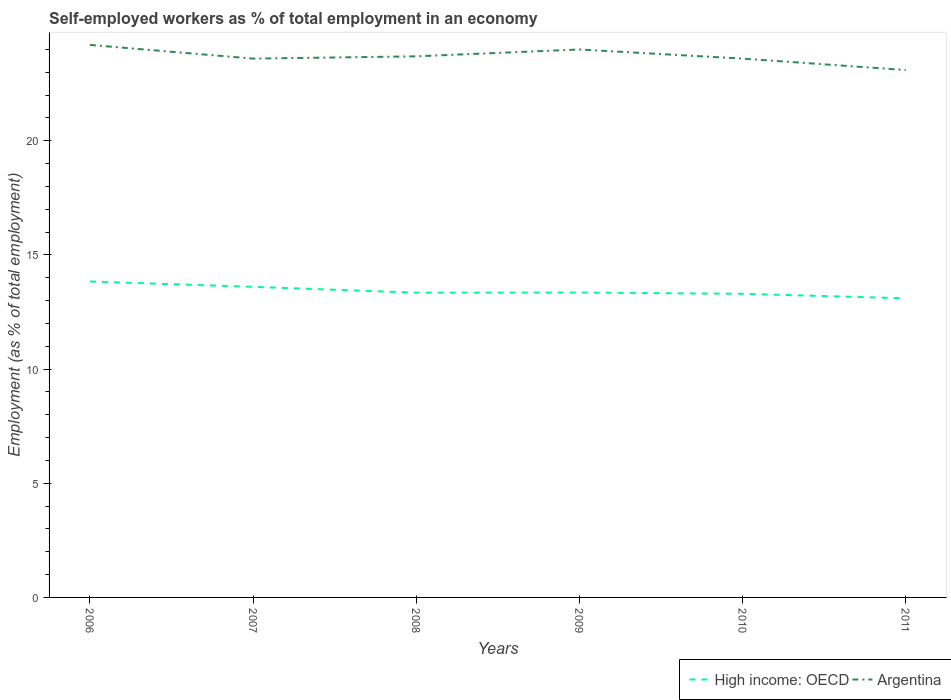Is the number of lines equal to the number of legend labels?
Offer a very short reply. Yes. Across all years, what is the maximum percentage of self-employed workers in Argentina?
Offer a very short reply. 23.1. In which year was the percentage of self-employed workers in High income: OECD maximum?
Ensure brevity in your answer.  2011. What is the total percentage of self-employed workers in High income: OECD in the graph?
Your response must be concise. 0.26. What is the difference between the highest and the second highest percentage of self-employed workers in High income: OECD?
Your answer should be compact. 0.74. How many years are there in the graph?
Offer a very short reply. 6. What is the difference between two consecutive major ticks on the Y-axis?
Your answer should be very brief. 5. Does the graph contain any zero values?
Offer a terse response. No. Does the graph contain grids?
Your answer should be very brief. No. How many legend labels are there?
Your answer should be compact. 2. How are the legend labels stacked?
Your answer should be very brief. Horizontal. What is the title of the graph?
Keep it short and to the point. Self-employed workers as % of total employment in an economy. What is the label or title of the X-axis?
Your answer should be very brief. Years. What is the label or title of the Y-axis?
Give a very brief answer. Employment (as % of total employment). What is the Employment (as % of total employment) in High income: OECD in 2006?
Offer a very short reply. 13.84. What is the Employment (as % of total employment) in Argentina in 2006?
Keep it short and to the point. 24.2. What is the Employment (as % of total employment) of High income: OECD in 2007?
Give a very brief answer. 13.6. What is the Employment (as % of total employment) of Argentina in 2007?
Your answer should be compact. 23.6. What is the Employment (as % of total employment) of High income: OECD in 2008?
Your answer should be compact. 13.35. What is the Employment (as % of total employment) of Argentina in 2008?
Give a very brief answer. 23.7. What is the Employment (as % of total employment) of High income: OECD in 2009?
Offer a very short reply. 13.35. What is the Employment (as % of total employment) in Argentina in 2009?
Offer a very short reply. 24. What is the Employment (as % of total employment) of High income: OECD in 2010?
Ensure brevity in your answer.  13.3. What is the Employment (as % of total employment) in Argentina in 2010?
Ensure brevity in your answer.  23.6. What is the Employment (as % of total employment) in High income: OECD in 2011?
Provide a succinct answer. 13.1. What is the Employment (as % of total employment) of Argentina in 2011?
Your response must be concise. 23.1. Across all years, what is the maximum Employment (as % of total employment) of High income: OECD?
Ensure brevity in your answer.  13.84. Across all years, what is the maximum Employment (as % of total employment) of Argentina?
Offer a terse response. 24.2. Across all years, what is the minimum Employment (as % of total employment) in High income: OECD?
Provide a short and direct response. 13.1. Across all years, what is the minimum Employment (as % of total employment) in Argentina?
Offer a terse response. 23.1. What is the total Employment (as % of total employment) of High income: OECD in the graph?
Your response must be concise. 80.55. What is the total Employment (as % of total employment) in Argentina in the graph?
Your response must be concise. 142.2. What is the difference between the Employment (as % of total employment) in High income: OECD in 2006 and that in 2007?
Ensure brevity in your answer.  0.23. What is the difference between the Employment (as % of total employment) in Argentina in 2006 and that in 2007?
Your answer should be very brief. 0.6. What is the difference between the Employment (as % of total employment) in High income: OECD in 2006 and that in 2008?
Provide a succinct answer. 0.49. What is the difference between the Employment (as % of total employment) in High income: OECD in 2006 and that in 2009?
Keep it short and to the point. 0.48. What is the difference between the Employment (as % of total employment) of High income: OECD in 2006 and that in 2010?
Keep it short and to the point. 0.54. What is the difference between the Employment (as % of total employment) in Argentina in 2006 and that in 2010?
Offer a terse response. 0.6. What is the difference between the Employment (as % of total employment) of High income: OECD in 2006 and that in 2011?
Your answer should be compact. 0.74. What is the difference between the Employment (as % of total employment) of Argentina in 2006 and that in 2011?
Provide a succinct answer. 1.1. What is the difference between the Employment (as % of total employment) of High income: OECD in 2007 and that in 2008?
Keep it short and to the point. 0.26. What is the difference between the Employment (as % of total employment) in Argentina in 2007 and that in 2008?
Provide a short and direct response. -0.1. What is the difference between the Employment (as % of total employment) in High income: OECD in 2007 and that in 2009?
Your answer should be very brief. 0.25. What is the difference between the Employment (as % of total employment) of Argentina in 2007 and that in 2009?
Your response must be concise. -0.4. What is the difference between the Employment (as % of total employment) in High income: OECD in 2007 and that in 2010?
Offer a very short reply. 0.31. What is the difference between the Employment (as % of total employment) of Argentina in 2007 and that in 2010?
Your answer should be compact. 0. What is the difference between the Employment (as % of total employment) of High income: OECD in 2007 and that in 2011?
Your answer should be compact. 0.5. What is the difference between the Employment (as % of total employment) of High income: OECD in 2008 and that in 2009?
Ensure brevity in your answer.  -0.01. What is the difference between the Employment (as % of total employment) of High income: OECD in 2008 and that in 2010?
Offer a very short reply. 0.05. What is the difference between the Employment (as % of total employment) in High income: OECD in 2008 and that in 2011?
Give a very brief answer. 0.25. What is the difference between the Employment (as % of total employment) of Argentina in 2008 and that in 2011?
Offer a terse response. 0.6. What is the difference between the Employment (as % of total employment) in High income: OECD in 2009 and that in 2010?
Offer a terse response. 0.06. What is the difference between the Employment (as % of total employment) in High income: OECD in 2009 and that in 2011?
Make the answer very short. 0.25. What is the difference between the Employment (as % of total employment) in Argentina in 2009 and that in 2011?
Ensure brevity in your answer.  0.9. What is the difference between the Employment (as % of total employment) of High income: OECD in 2010 and that in 2011?
Your response must be concise. 0.2. What is the difference between the Employment (as % of total employment) in Argentina in 2010 and that in 2011?
Offer a very short reply. 0.5. What is the difference between the Employment (as % of total employment) of High income: OECD in 2006 and the Employment (as % of total employment) of Argentina in 2007?
Provide a short and direct response. -9.76. What is the difference between the Employment (as % of total employment) of High income: OECD in 2006 and the Employment (as % of total employment) of Argentina in 2008?
Your answer should be very brief. -9.86. What is the difference between the Employment (as % of total employment) in High income: OECD in 2006 and the Employment (as % of total employment) in Argentina in 2009?
Your answer should be compact. -10.16. What is the difference between the Employment (as % of total employment) of High income: OECD in 2006 and the Employment (as % of total employment) of Argentina in 2010?
Provide a succinct answer. -9.76. What is the difference between the Employment (as % of total employment) of High income: OECD in 2006 and the Employment (as % of total employment) of Argentina in 2011?
Provide a short and direct response. -9.26. What is the difference between the Employment (as % of total employment) of High income: OECD in 2007 and the Employment (as % of total employment) of Argentina in 2008?
Keep it short and to the point. -10.1. What is the difference between the Employment (as % of total employment) of High income: OECD in 2007 and the Employment (as % of total employment) of Argentina in 2009?
Provide a short and direct response. -10.4. What is the difference between the Employment (as % of total employment) in High income: OECD in 2007 and the Employment (as % of total employment) in Argentina in 2010?
Offer a terse response. -10. What is the difference between the Employment (as % of total employment) in High income: OECD in 2007 and the Employment (as % of total employment) in Argentina in 2011?
Your answer should be compact. -9.5. What is the difference between the Employment (as % of total employment) of High income: OECD in 2008 and the Employment (as % of total employment) of Argentina in 2009?
Make the answer very short. -10.65. What is the difference between the Employment (as % of total employment) in High income: OECD in 2008 and the Employment (as % of total employment) in Argentina in 2010?
Ensure brevity in your answer.  -10.25. What is the difference between the Employment (as % of total employment) in High income: OECD in 2008 and the Employment (as % of total employment) in Argentina in 2011?
Ensure brevity in your answer.  -9.75. What is the difference between the Employment (as % of total employment) in High income: OECD in 2009 and the Employment (as % of total employment) in Argentina in 2010?
Your answer should be very brief. -10.25. What is the difference between the Employment (as % of total employment) in High income: OECD in 2009 and the Employment (as % of total employment) in Argentina in 2011?
Ensure brevity in your answer.  -9.75. What is the difference between the Employment (as % of total employment) in High income: OECD in 2010 and the Employment (as % of total employment) in Argentina in 2011?
Your answer should be very brief. -9.8. What is the average Employment (as % of total employment) of High income: OECD per year?
Ensure brevity in your answer.  13.42. What is the average Employment (as % of total employment) of Argentina per year?
Provide a short and direct response. 23.7. In the year 2006, what is the difference between the Employment (as % of total employment) in High income: OECD and Employment (as % of total employment) in Argentina?
Your response must be concise. -10.36. In the year 2007, what is the difference between the Employment (as % of total employment) in High income: OECD and Employment (as % of total employment) in Argentina?
Give a very brief answer. -10. In the year 2008, what is the difference between the Employment (as % of total employment) in High income: OECD and Employment (as % of total employment) in Argentina?
Your answer should be very brief. -10.35. In the year 2009, what is the difference between the Employment (as % of total employment) in High income: OECD and Employment (as % of total employment) in Argentina?
Your answer should be compact. -10.65. In the year 2010, what is the difference between the Employment (as % of total employment) in High income: OECD and Employment (as % of total employment) in Argentina?
Offer a terse response. -10.3. In the year 2011, what is the difference between the Employment (as % of total employment) of High income: OECD and Employment (as % of total employment) of Argentina?
Your answer should be very brief. -10. What is the ratio of the Employment (as % of total employment) of High income: OECD in 2006 to that in 2007?
Offer a very short reply. 1.02. What is the ratio of the Employment (as % of total employment) of Argentina in 2006 to that in 2007?
Your response must be concise. 1.03. What is the ratio of the Employment (as % of total employment) of High income: OECD in 2006 to that in 2008?
Your answer should be very brief. 1.04. What is the ratio of the Employment (as % of total employment) of Argentina in 2006 to that in 2008?
Your response must be concise. 1.02. What is the ratio of the Employment (as % of total employment) in High income: OECD in 2006 to that in 2009?
Your response must be concise. 1.04. What is the ratio of the Employment (as % of total employment) of Argentina in 2006 to that in 2009?
Make the answer very short. 1.01. What is the ratio of the Employment (as % of total employment) of High income: OECD in 2006 to that in 2010?
Give a very brief answer. 1.04. What is the ratio of the Employment (as % of total employment) in Argentina in 2006 to that in 2010?
Give a very brief answer. 1.03. What is the ratio of the Employment (as % of total employment) of High income: OECD in 2006 to that in 2011?
Your response must be concise. 1.06. What is the ratio of the Employment (as % of total employment) in Argentina in 2006 to that in 2011?
Provide a short and direct response. 1.05. What is the ratio of the Employment (as % of total employment) of High income: OECD in 2007 to that in 2008?
Give a very brief answer. 1.02. What is the ratio of the Employment (as % of total employment) in Argentina in 2007 to that in 2008?
Provide a short and direct response. 1. What is the ratio of the Employment (as % of total employment) of High income: OECD in 2007 to that in 2009?
Your response must be concise. 1.02. What is the ratio of the Employment (as % of total employment) in Argentina in 2007 to that in 2009?
Give a very brief answer. 0.98. What is the ratio of the Employment (as % of total employment) in High income: OECD in 2007 to that in 2011?
Offer a terse response. 1.04. What is the ratio of the Employment (as % of total employment) of Argentina in 2007 to that in 2011?
Ensure brevity in your answer.  1.02. What is the ratio of the Employment (as % of total employment) in Argentina in 2008 to that in 2009?
Keep it short and to the point. 0.99. What is the ratio of the Employment (as % of total employment) of High income: OECD in 2008 to that in 2010?
Your answer should be compact. 1. What is the ratio of the Employment (as % of total employment) of High income: OECD in 2008 to that in 2011?
Your answer should be very brief. 1.02. What is the ratio of the Employment (as % of total employment) in Argentina in 2008 to that in 2011?
Offer a terse response. 1.03. What is the ratio of the Employment (as % of total employment) of High income: OECD in 2009 to that in 2010?
Your response must be concise. 1. What is the ratio of the Employment (as % of total employment) in Argentina in 2009 to that in 2010?
Offer a terse response. 1.02. What is the ratio of the Employment (as % of total employment) in High income: OECD in 2009 to that in 2011?
Keep it short and to the point. 1.02. What is the ratio of the Employment (as % of total employment) of Argentina in 2009 to that in 2011?
Give a very brief answer. 1.04. What is the ratio of the Employment (as % of total employment) in Argentina in 2010 to that in 2011?
Your answer should be compact. 1.02. What is the difference between the highest and the second highest Employment (as % of total employment) of High income: OECD?
Offer a terse response. 0.23. What is the difference between the highest and the second highest Employment (as % of total employment) of Argentina?
Provide a short and direct response. 0.2. What is the difference between the highest and the lowest Employment (as % of total employment) of High income: OECD?
Make the answer very short. 0.74. What is the difference between the highest and the lowest Employment (as % of total employment) of Argentina?
Keep it short and to the point. 1.1. 